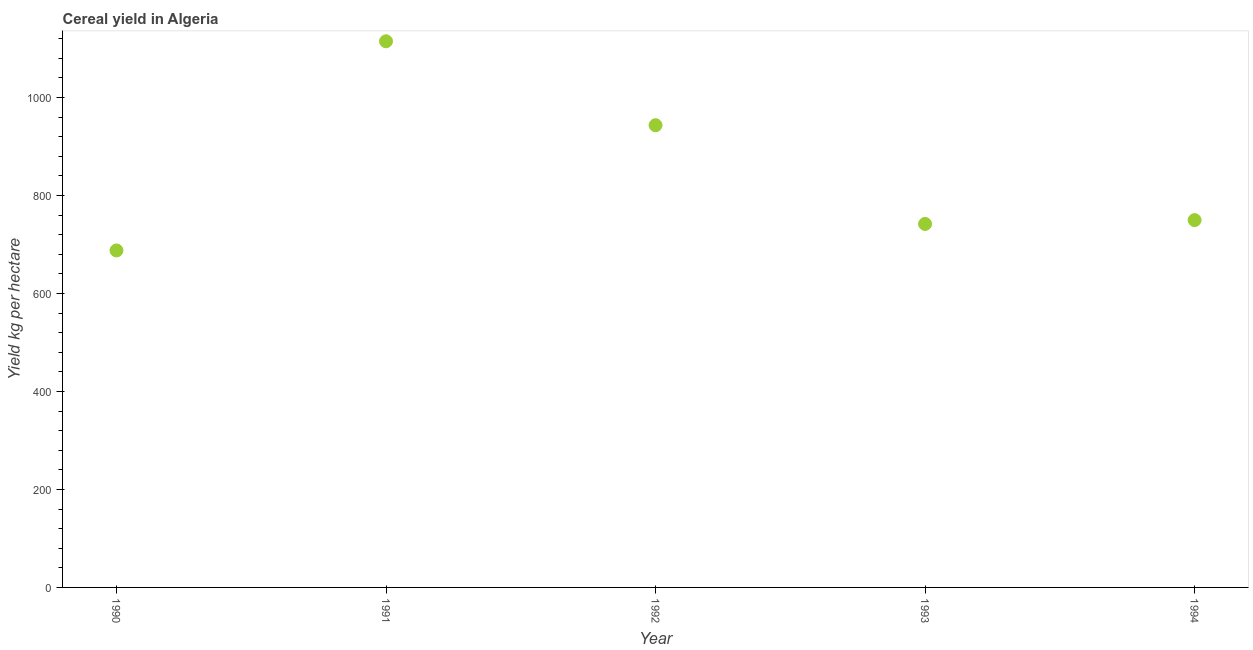What is the cereal yield in 1993?
Provide a short and direct response. 741.78. Across all years, what is the maximum cereal yield?
Make the answer very short. 1114.55. Across all years, what is the minimum cereal yield?
Give a very brief answer. 687.67. What is the sum of the cereal yield?
Ensure brevity in your answer.  4236.9. What is the difference between the cereal yield in 1990 and 1991?
Make the answer very short. -426.88. What is the average cereal yield per year?
Your answer should be compact. 847.38. What is the median cereal yield?
Your answer should be very brief. 749.61. In how many years, is the cereal yield greater than 440 kg per hectare?
Ensure brevity in your answer.  5. Do a majority of the years between 1990 and 1992 (inclusive) have cereal yield greater than 120 kg per hectare?
Ensure brevity in your answer.  Yes. What is the ratio of the cereal yield in 1991 to that in 1992?
Provide a succinct answer. 1.18. What is the difference between the highest and the second highest cereal yield?
Offer a terse response. 171.27. What is the difference between the highest and the lowest cereal yield?
Offer a terse response. 426.88. Does the cereal yield monotonically increase over the years?
Keep it short and to the point. No. How many dotlines are there?
Provide a succinct answer. 1. How many years are there in the graph?
Make the answer very short. 5. Are the values on the major ticks of Y-axis written in scientific E-notation?
Make the answer very short. No. Does the graph contain any zero values?
Your response must be concise. No. Does the graph contain grids?
Provide a succinct answer. No. What is the title of the graph?
Keep it short and to the point. Cereal yield in Algeria. What is the label or title of the X-axis?
Give a very brief answer. Year. What is the label or title of the Y-axis?
Provide a short and direct response. Yield kg per hectare. What is the Yield kg per hectare in 1990?
Provide a short and direct response. 687.67. What is the Yield kg per hectare in 1991?
Your response must be concise. 1114.55. What is the Yield kg per hectare in 1992?
Offer a terse response. 943.29. What is the Yield kg per hectare in 1993?
Your answer should be very brief. 741.78. What is the Yield kg per hectare in 1994?
Offer a terse response. 749.61. What is the difference between the Yield kg per hectare in 1990 and 1991?
Provide a short and direct response. -426.88. What is the difference between the Yield kg per hectare in 1990 and 1992?
Ensure brevity in your answer.  -255.61. What is the difference between the Yield kg per hectare in 1990 and 1993?
Provide a succinct answer. -54.11. What is the difference between the Yield kg per hectare in 1990 and 1994?
Your answer should be very brief. -61.94. What is the difference between the Yield kg per hectare in 1991 and 1992?
Make the answer very short. 171.27. What is the difference between the Yield kg per hectare in 1991 and 1993?
Offer a very short reply. 372.77. What is the difference between the Yield kg per hectare in 1991 and 1994?
Give a very brief answer. 364.94. What is the difference between the Yield kg per hectare in 1992 and 1993?
Ensure brevity in your answer.  201.51. What is the difference between the Yield kg per hectare in 1992 and 1994?
Make the answer very short. 193.68. What is the difference between the Yield kg per hectare in 1993 and 1994?
Offer a very short reply. -7.83. What is the ratio of the Yield kg per hectare in 1990 to that in 1991?
Give a very brief answer. 0.62. What is the ratio of the Yield kg per hectare in 1990 to that in 1992?
Your response must be concise. 0.73. What is the ratio of the Yield kg per hectare in 1990 to that in 1993?
Your answer should be compact. 0.93. What is the ratio of the Yield kg per hectare in 1990 to that in 1994?
Keep it short and to the point. 0.92. What is the ratio of the Yield kg per hectare in 1991 to that in 1992?
Your response must be concise. 1.18. What is the ratio of the Yield kg per hectare in 1991 to that in 1993?
Your response must be concise. 1.5. What is the ratio of the Yield kg per hectare in 1991 to that in 1994?
Provide a succinct answer. 1.49. What is the ratio of the Yield kg per hectare in 1992 to that in 1993?
Provide a succinct answer. 1.27. What is the ratio of the Yield kg per hectare in 1992 to that in 1994?
Keep it short and to the point. 1.26. What is the ratio of the Yield kg per hectare in 1993 to that in 1994?
Provide a short and direct response. 0.99. 